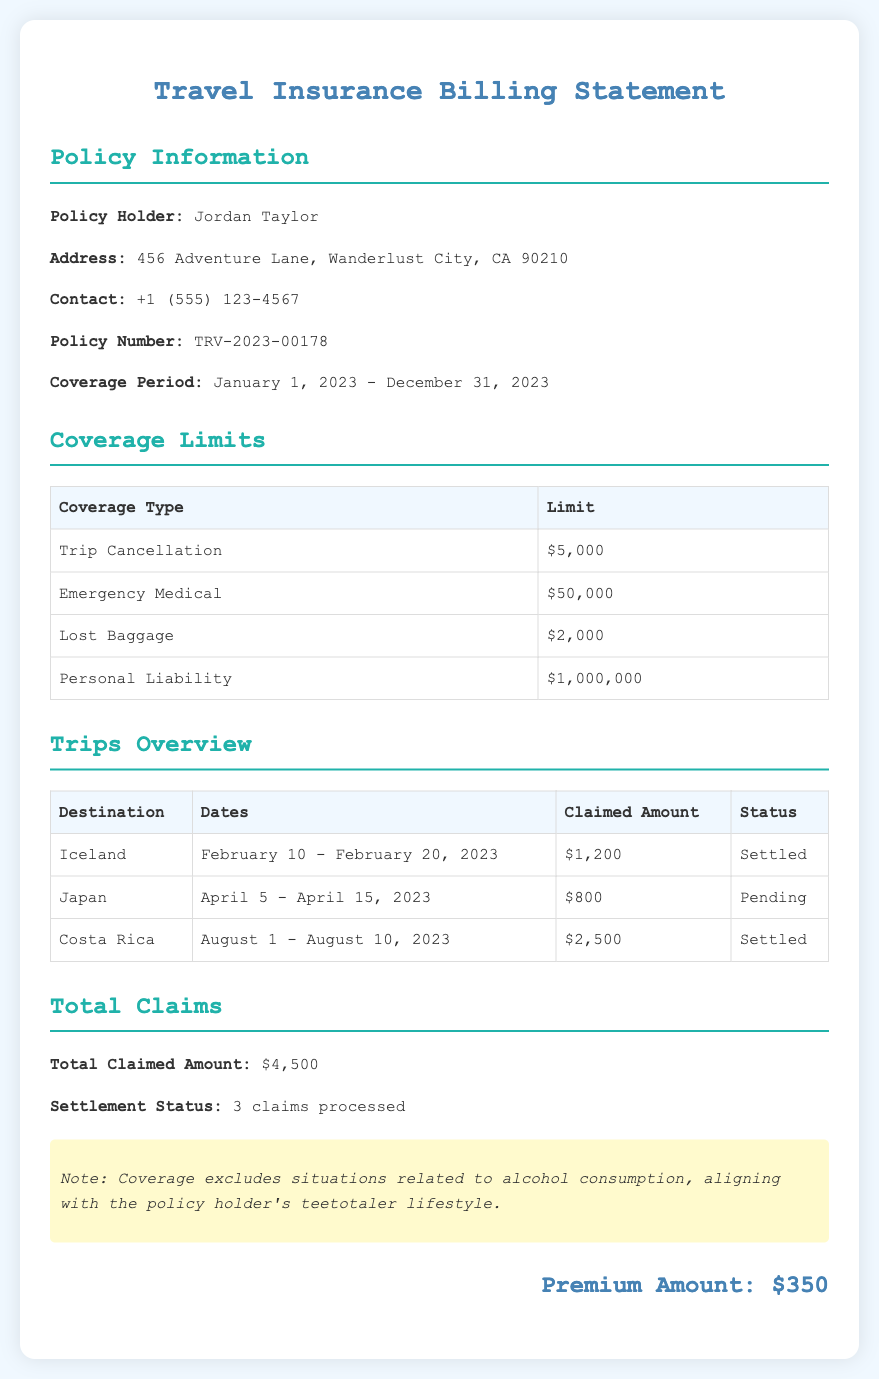What is the policy holder's name? The policy holder's name is mentioned in the policy information section.
Answer: Jordan Taylor What is the coverage period of the policy? The coverage period is specifically stated in the document.
Answer: January 1, 2023 - December 31, 2023 What is the limit for emergency medical coverage? The limit for emergency medical coverage can be found in the coverage limits table.
Answer: $50,000 How many claims have been settled? The total number of settled claims is provided in the total claims section.
Answer: 3 claims processed What was the claimed amount for the trip to Japan? The claimed amount for the trip to Japan is listed in the trips overview table.
Answer: $800 What is the premium amount for the insurance policy? The premium amount is provided at the bottom of the document.
Answer: $350 What is noted about coverage related to alcohol consumption? The document includes a specific note regarding alcohol consumption.
Answer: Excludes situations related to alcohol consumption Which trip had the highest claimed amount? The trip with the highest claimed amount can be identified by comparing the claimed amounts in the trips table.
Answer: Costa Rica, $2,500 What is the status of the claim for the trip to Iceland? The status can be found in the trips overview table where each claim status is listed.
Answer: Settled 